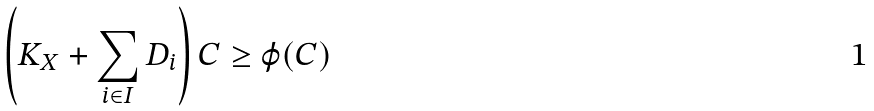Convert formula to latex. <formula><loc_0><loc_0><loc_500><loc_500>\left ( K _ { X } + \sum _ { i \in I } D _ { i } \right ) C \geq \varphi ( C )</formula> 